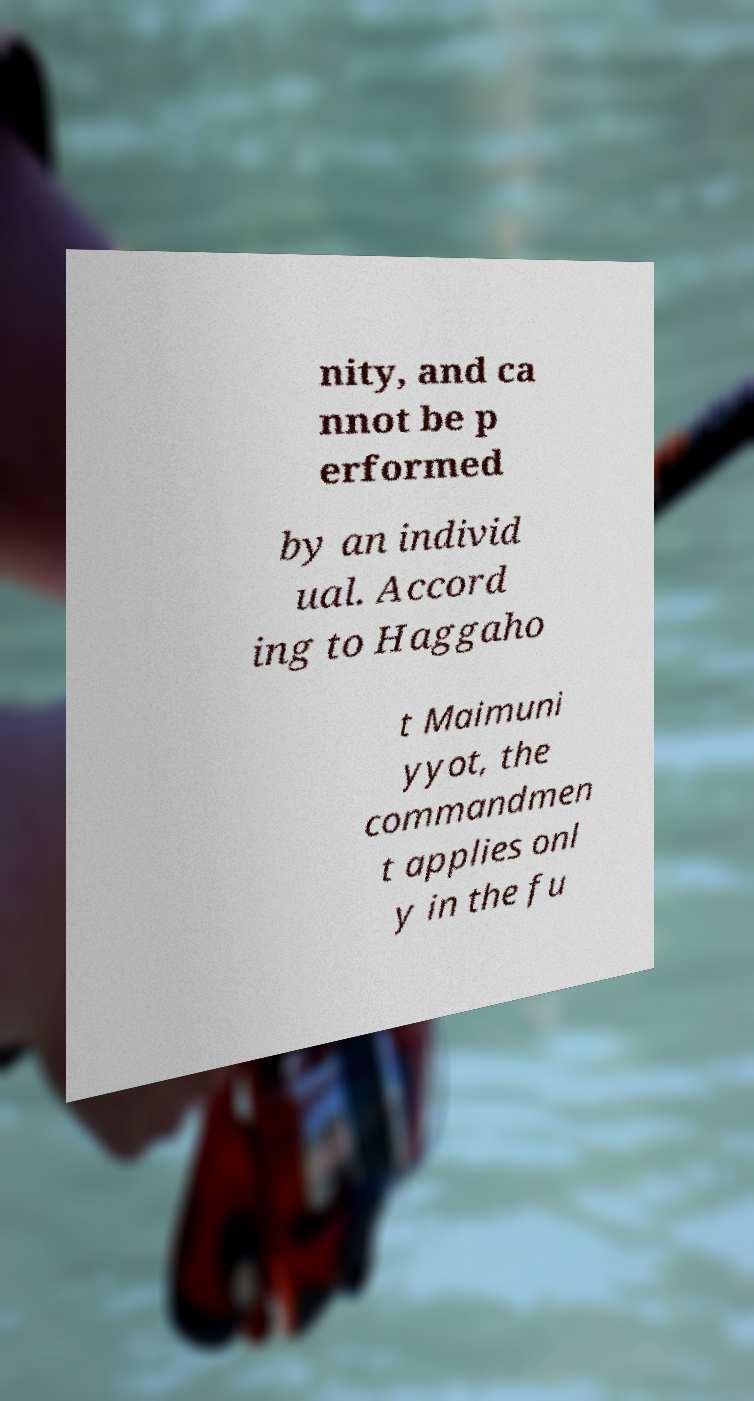Could you extract and type out the text from this image? nity, and ca nnot be p erformed by an individ ual. Accord ing to Haggaho t Maimuni yyot, the commandmen t applies onl y in the fu 